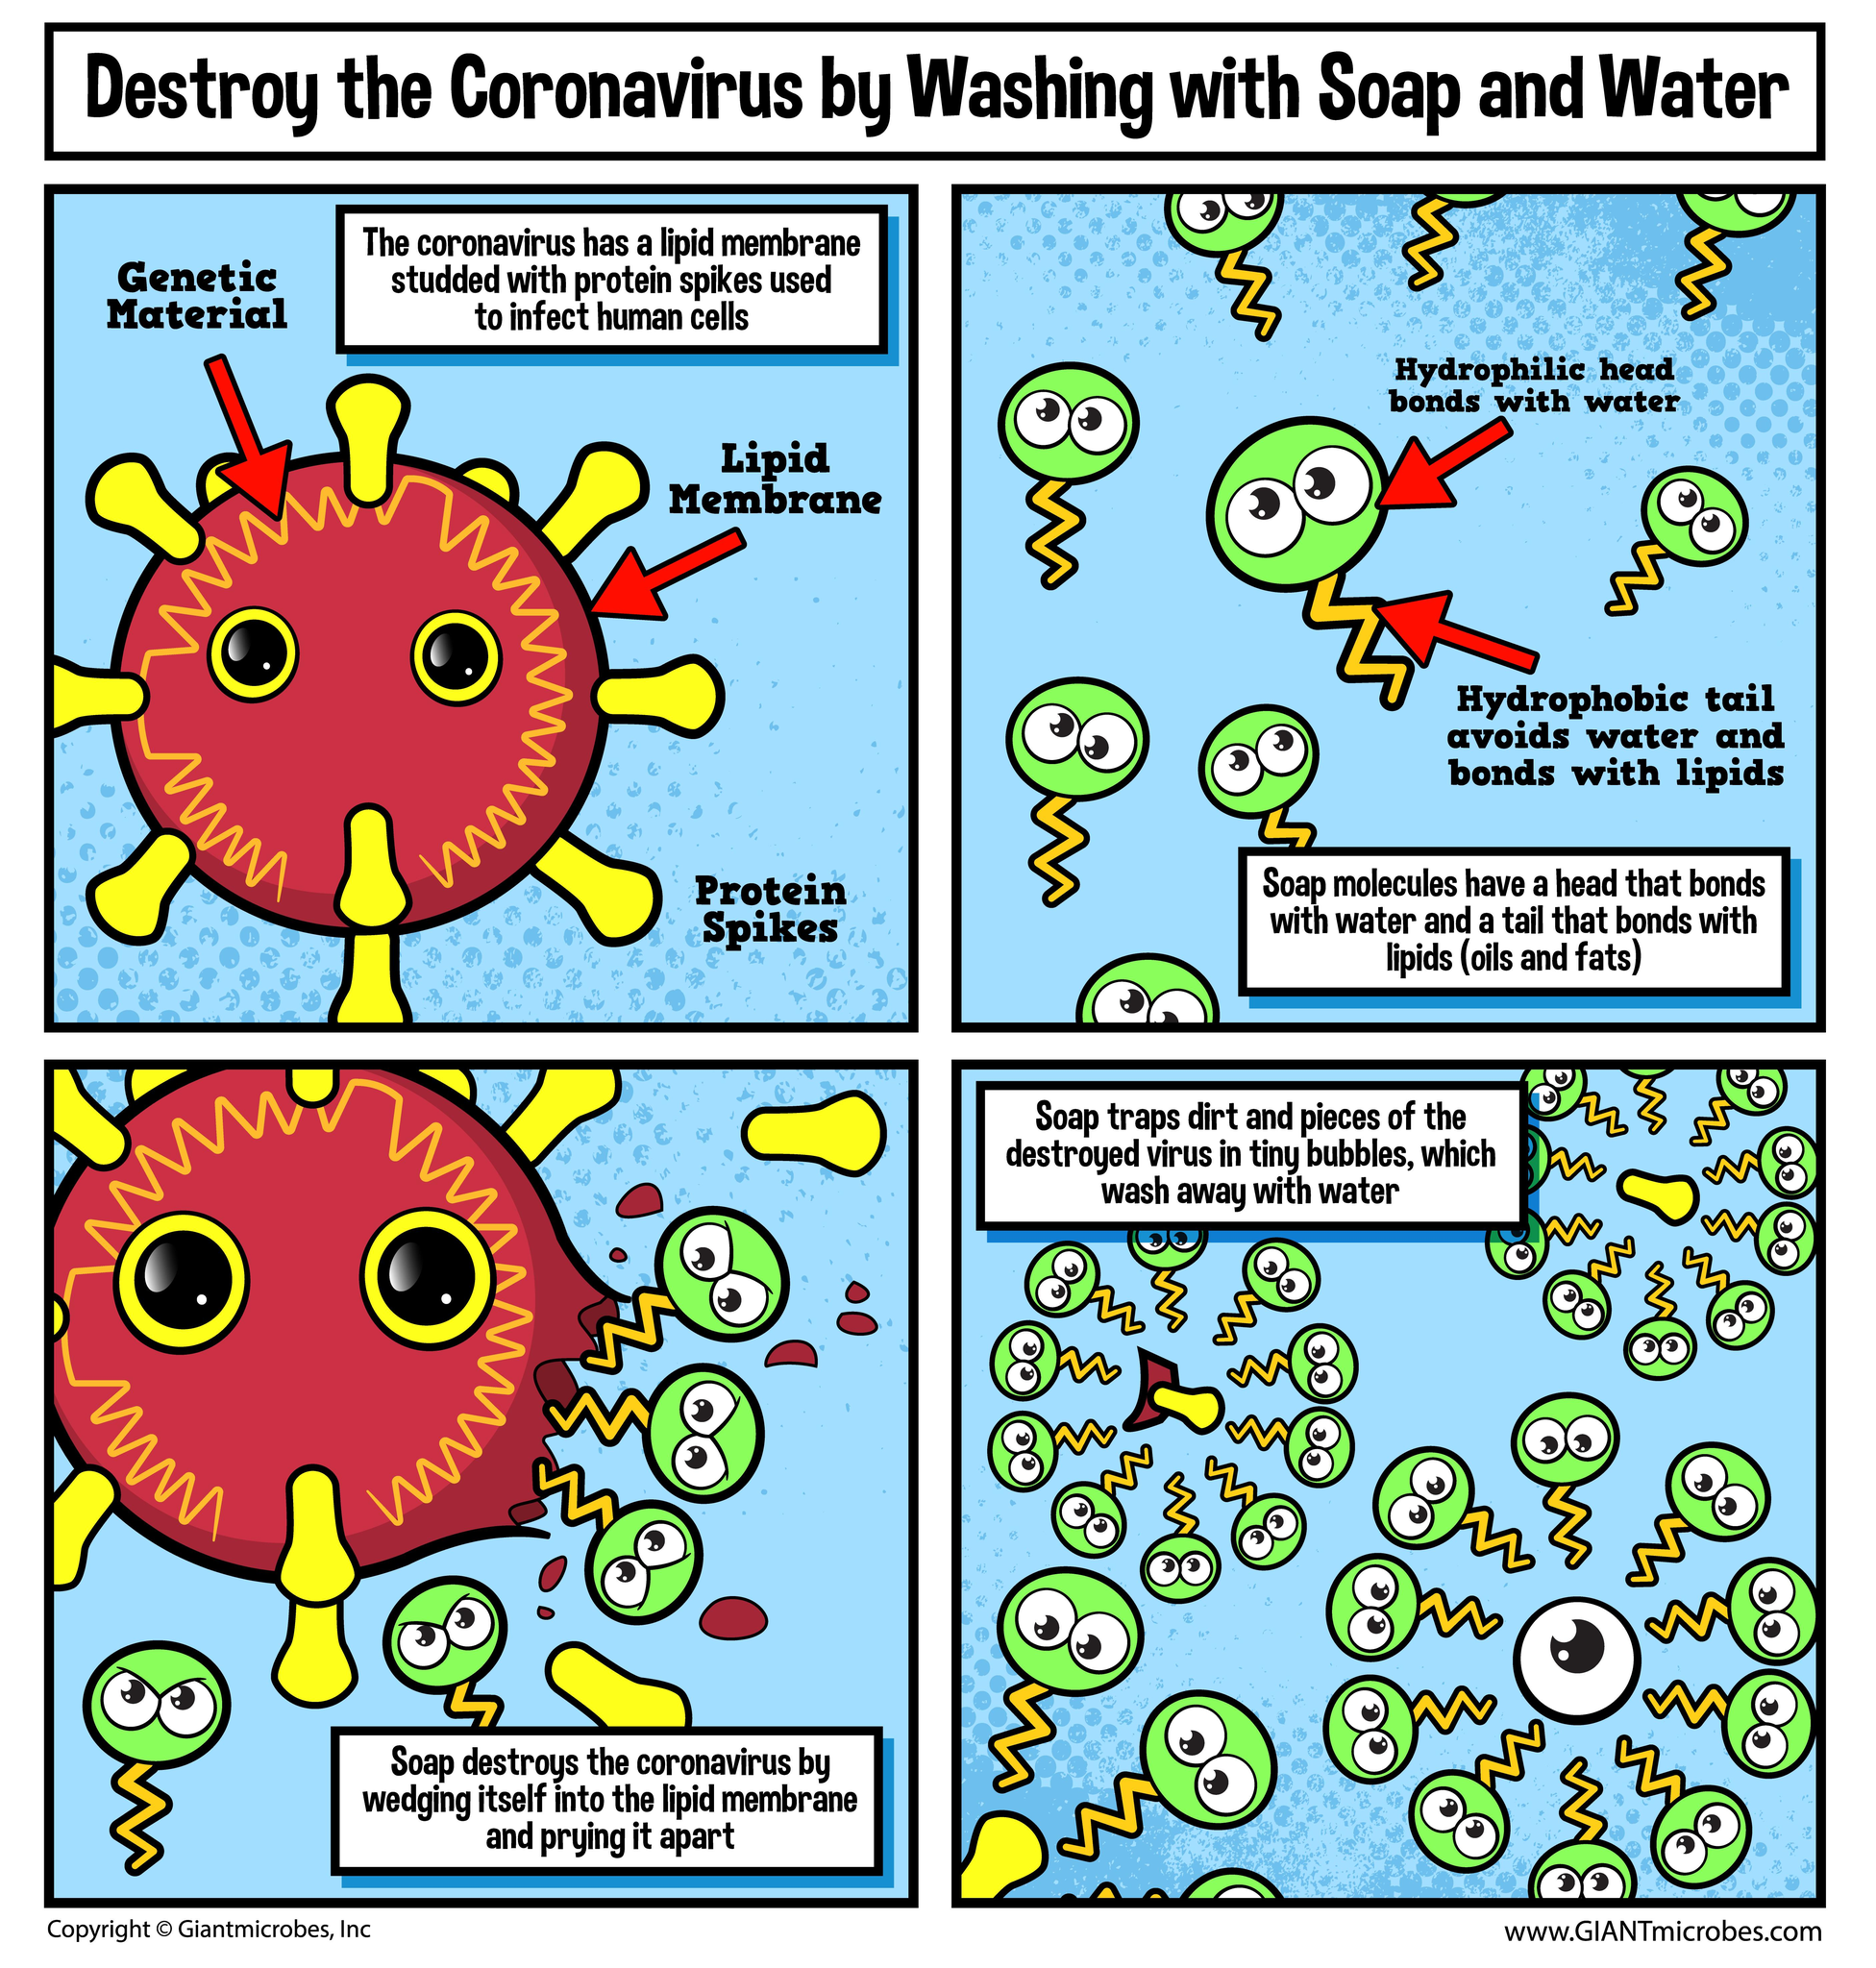Indicate a few pertinent items in this graphic. The coronavirus is composed of three main structural components: genetic material, a lipid membrane, and protein spikes. The protein spike is yellow in color. Soap molecules consist of a hydrophilic head and a hydrophobic tail. The color of the soap head is green. 